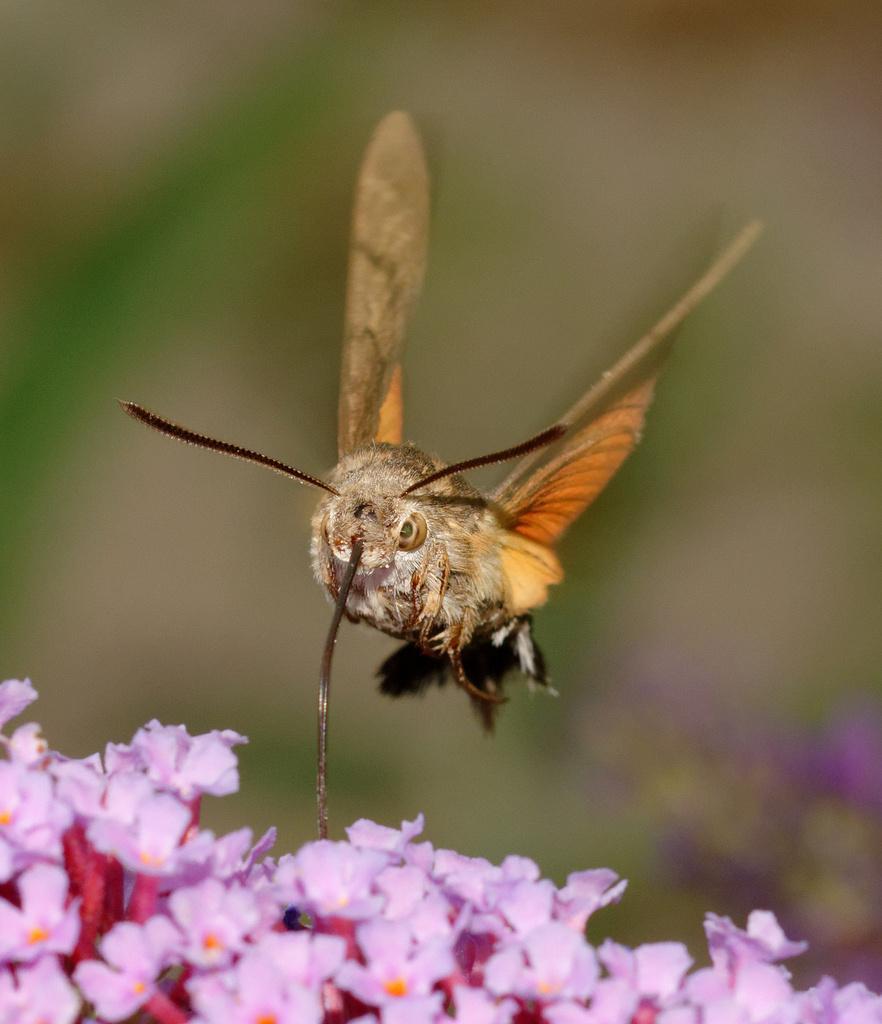How would you summarize this image in a sentence or two? At the bottom of this image there are some flowers. On the flowers there is a bee. The background is blurred. 